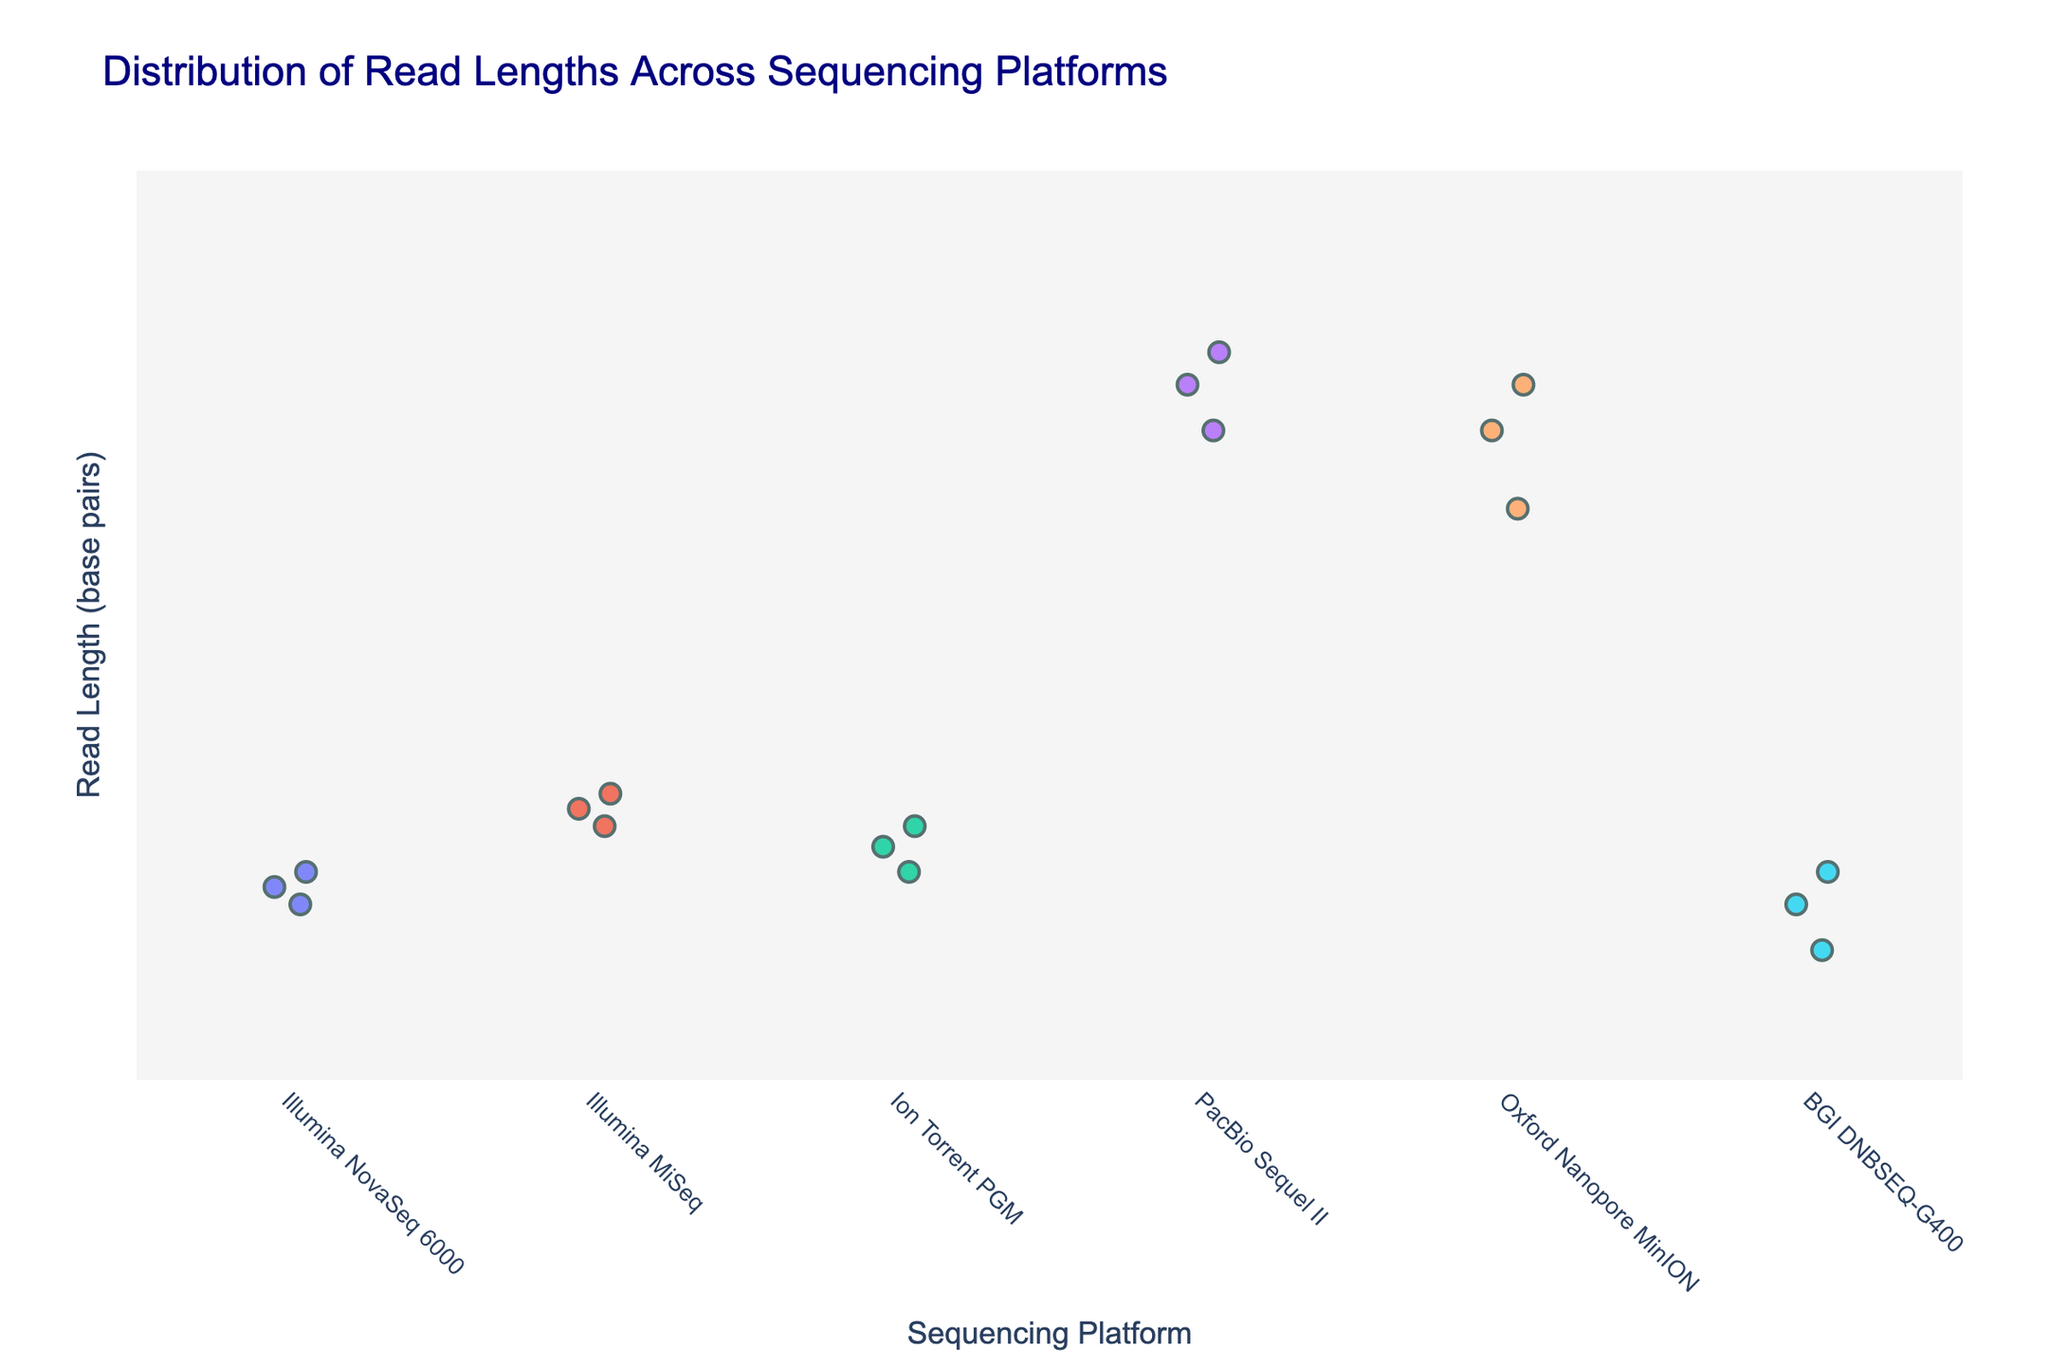How many sequencing platforms are present in the strip plot? The x-axis shows different sequencing platforms with data points distributed above each. Counting them gives the number of platforms.
Answer: 5 What is the shortest read length observed for BGI DNBSEQ-G400? Look at the y-axis values corresponding to the data points above BGI DNBSEQ-G400. Identify the lowest point in terms of read length.
Answer: 100 Which platform has the widest range of read lengths? Observe the range of read lengths for each platform by noting the highest and lowest points on the y-axis for each platform. The platform with the largest difference between these values has the widest range.
Answer: PacBio Sequel II Does the Illumina MiSeq platform have any data points with read lengths above 400? Look at the read lengths for the data points associated with Illumina MiSeq and check if any points fall above the 400 mark.
Answer: No Compare the median read lengths of Illumina NovaSeq 6000 and Ion Torrent PGM. Which one is higher? For both platforms, look at their data points' read lengths. The median is the middle data point when read lengths are arranged in ascending order. Compare these median values.
Answer: Ion Torrent PGM What is the read length range for Oxford Nanopore MinION? Identify the lowest and highest read lengths among the data points for Oxford Nanopore MinION. Subtract the smallest read length from the largest for the range.
Answer: 5 to 15 kb (5000 to 15000) Arrange the platforms in descending order based on their maximum read length. Identify the maximum read length for each platform and then sort these from the highest to lowest.
Answer: PacBio Sequel II, Oxford Nanopore MinION, Illumina MiSeq, Ion Torrent PGM, Illumina NovaSeq 6000, BGI DNBSEQ-G400 What is the average read length for Illumina NovaSeq 6000? Sum the read lengths for Illumina NovaSeq 6000 and divide by the number of data points (3).
Answer: 175 